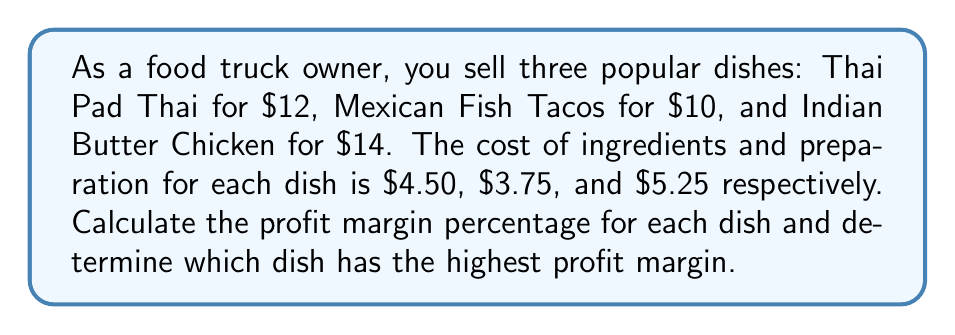Can you solve this math problem? To solve this problem, we need to follow these steps for each dish:

1. Calculate the profit per dish
2. Calculate the profit margin percentage
3. Compare the profit margins

Let's go through each dish:

1. Thai Pad Thai:
   - Selling price: $12
   - Cost: $4.50
   - Profit: $12 - $4.50 = $7.50
   - Profit margin: $\frac{\text{Profit}}{\text{Selling Price}} \times 100\%$
   $$\frac{7.50}{12} \times 100\% = 62.5\%$$

2. Mexican Fish Tacos:
   - Selling price: $10
   - Cost: $3.75
   - Profit: $10 - $3.75 = $6.25
   - Profit margin: $\frac{\text{Profit}}{\text{Selling Price}} \times 100\%$
   $$\frac{6.25}{10} \times 100\% = 62.5\%$$

3. Indian Butter Chicken:
   - Selling price: $14
   - Cost: $5.25
   - Profit: $14 - $5.25 = $8.75
   - Profit margin: $\frac{\text{Profit}}{\text{Selling Price}} \times 100\%$
   $$\frac{8.75}{14} \times 100\% = 62.5\%$$

Comparing the profit margins:
Thai Pad Thai: 62.5%
Mexican Fish Tacos: 62.5%
Indian Butter Chicken: 62.5%

All three dishes have the same profit margin percentage.
Answer: All three dishes have the same profit margin of 62.5%. There is no single dish with the highest profit margin; they are all equally profitable in terms of percentage. 